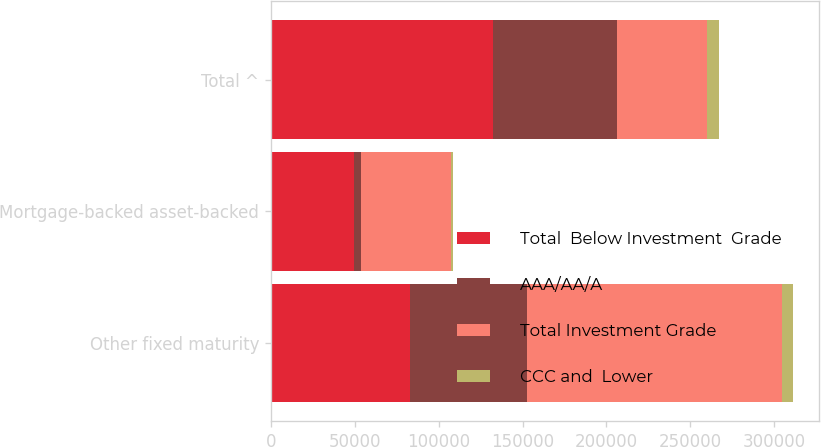<chart> <loc_0><loc_0><loc_500><loc_500><stacked_bar_chart><ecel><fcel>Other fixed maturity<fcel>Mortgage-backed asset-backed<fcel>Total ^<nl><fcel>Total  Below Investment  Grade<fcel>82798<fcel>49521<fcel>132319<nl><fcel>AAA/AA/A<fcel>69609<fcel>4210<fcel>73819<nl><fcel>Total Investment Grade<fcel>152407<fcel>53731<fcel>53731<nl><fcel>CCC and  Lower<fcel>6174<fcel>1220<fcel>7394<nl></chart> 